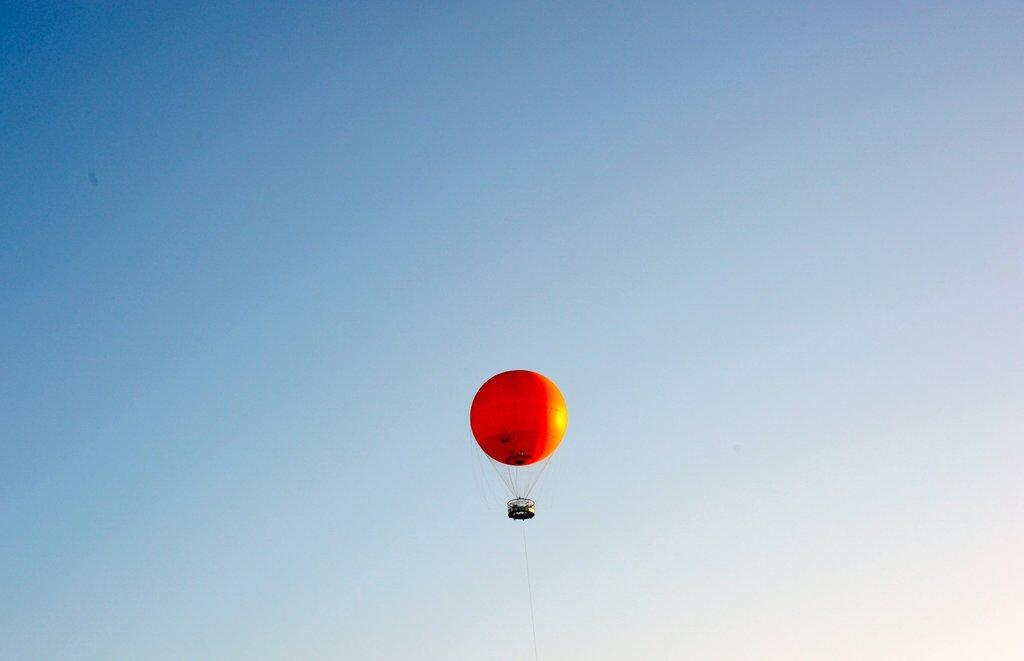What object is present in the image? There is a balloon in the image. What can be seen in the background of the image? The sky is visible in the background of the image. What type of cheese is being used to create a connection between the balloon and the sky? There is no cheese present in the image, and the balloon is not connected to the sky. 